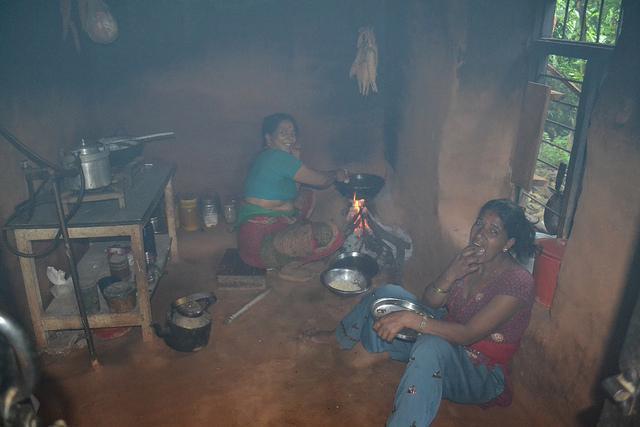How many windows?
Give a very brief answer. 2. How many people are there?
Give a very brief answer. 2. 